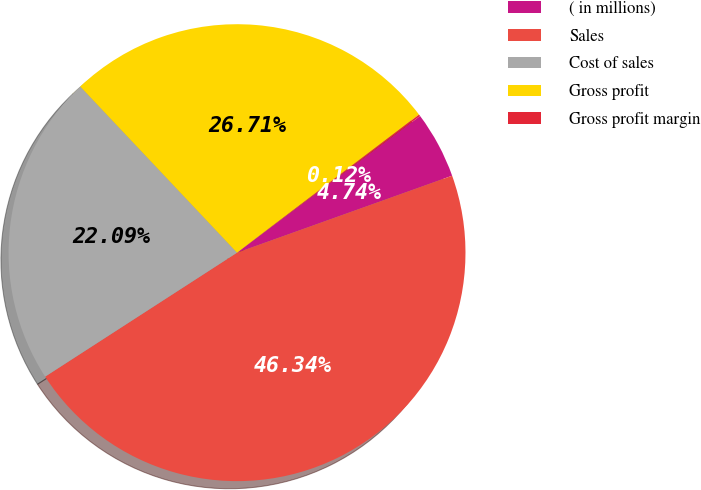<chart> <loc_0><loc_0><loc_500><loc_500><pie_chart><fcel>( in millions)<fcel>Sales<fcel>Cost of sales<fcel>Gross profit<fcel>Gross profit margin<nl><fcel>4.74%<fcel>46.34%<fcel>22.09%<fcel>26.71%<fcel>0.12%<nl></chart> 